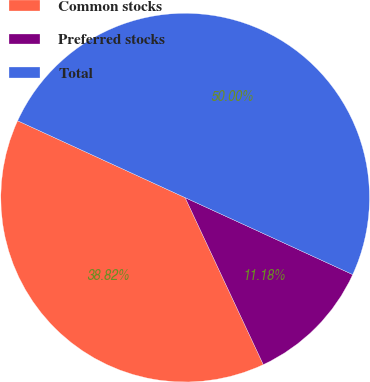<chart> <loc_0><loc_0><loc_500><loc_500><pie_chart><fcel>Common stocks<fcel>Preferred stocks<fcel>Total<nl><fcel>38.82%<fcel>11.18%<fcel>50.0%<nl></chart> 